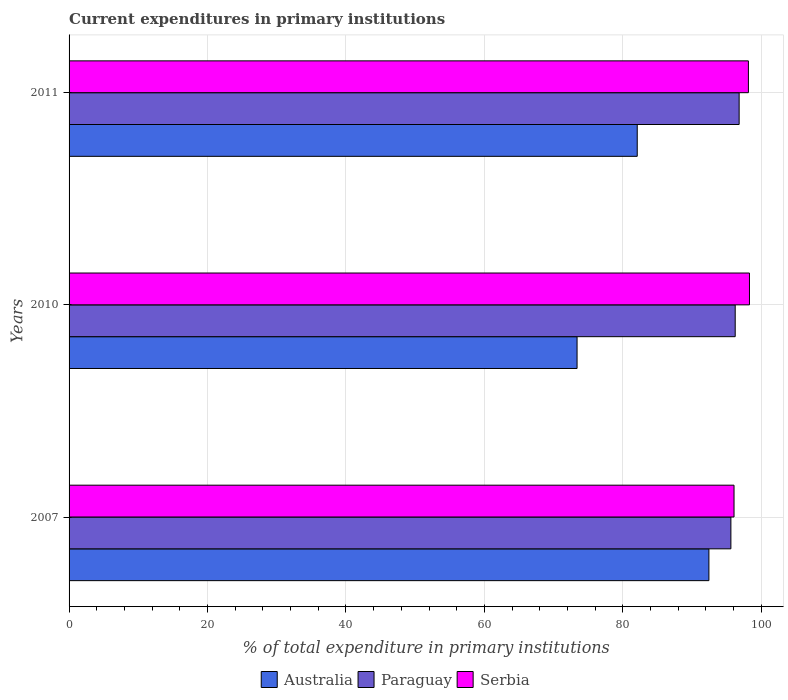How many groups of bars are there?
Your answer should be very brief. 3. Are the number of bars per tick equal to the number of legend labels?
Your answer should be compact. Yes. How many bars are there on the 3rd tick from the bottom?
Keep it short and to the point. 3. What is the label of the 3rd group of bars from the top?
Your answer should be very brief. 2007. In how many cases, is the number of bars for a given year not equal to the number of legend labels?
Your answer should be compact. 0. What is the current expenditures in primary institutions in Australia in 2007?
Ensure brevity in your answer.  92.42. Across all years, what is the maximum current expenditures in primary institutions in Serbia?
Provide a succinct answer. 98.28. Across all years, what is the minimum current expenditures in primary institutions in Paraguay?
Offer a very short reply. 95.6. What is the total current expenditures in primary institutions in Paraguay in the graph?
Your answer should be very brief. 288.61. What is the difference between the current expenditures in primary institutions in Australia in 2010 and that in 2011?
Provide a short and direct response. -8.69. What is the difference between the current expenditures in primary institutions in Serbia in 2011 and the current expenditures in primary institutions in Paraguay in 2007?
Keep it short and to the point. 2.53. What is the average current expenditures in primary institutions in Paraguay per year?
Give a very brief answer. 96.2. In the year 2011, what is the difference between the current expenditures in primary institutions in Serbia and current expenditures in primary institutions in Paraguay?
Your response must be concise. 1.34. What is the ratio of the current expenditures in primary institutions in Paraguay in 2007 to that in 2011?
Offer a very short reply. 0.99. What is the difference between the highest and the second highest current expenditures in primary institutions in Paraguay?
Your answer should be very brief. 0.57. What is the difference between the highest and the lowest current expenditures in primary institutions in Serbia?
Make the answer very short. 2.23. What does the 2nd bar from the top in 2011 represents?
Ensure brevity in your answer.  Paraguay. What does the 3rd bar from the bottom in 2007 represents?
Your response must be concise. Serbia. Are all the bars in the graph horizontal?
Make the answer very short. Yes. What is the difference between two consecutive major ticks on the X-axis?
Give a very brief answer. 20. Does the graph contain any zero values?
Your answer should be very brief. No. Does the graph contain grids?
Your answer should be compact. Yes. What is the title of the graph?
Your answer should be very brief. Current expenditures in primary institutions. Does "Papua New Guinea" appear as one of the legend labels in the graph?
Provide a short and direct response. No. What is the label or title of the X-axis?
Your answer should be very brief. % of total expenditure in primary institutions. What is the label or title of the Y-axis?
Keep it short and to the point. Years. What is the % of total expenditure in primary institutions of Australia in 2007?
Your answer should be very brief. 92.42. What is the % of total expenditure in primary institutions of Paraguay in 2007?
Your response must be concise. 95.6. What is the % of total expenditure in primary institutions of Serbia in 2007?
Keep it short and to the point. 96.05. What is the % of total expenditure in primary institutions in Australia in 2010?
Your answer should be very brief. 73.38. What is the % of total expenditure in primary institutions in Paraguay in 2010?
Your answer should be very brief. 96.22. What is the % of total expenditure in primary institutions of Serbia in 2010?
Offer a very short reply. 98.28. What is the % of total expenditure in primary institutions in Australia in 2011?
Offer a terse response. 82.07. What is the % of total expenditure in primary institutions of Paraguay in 2011?
Your response must be concise. 96.79. What is the % of total expenditure in primary institutions in Serbia in 2011?
Give a very brief answer. 98.13. Across all years, what is the maximum % of total expenditure in primary institutions in Australia?
Your answer should be compact. 92.42. Across all years, what is the maximum % of total expenditure in primary institutions in Paraguay?
Your answer should be compact. 96.79. Across all years, what is the maximum % of total expenditure in primary institutions of Serbia?
Your answer should be very brief. 98.28. Across all years, what is the minimum % of total expenditure in primary institutions in Australia?
Provide a short and direct response. 73.38. Across all years, what is the minimum % of total expenditure in primary institutions of Paraguay?
Your answer should be very brief. 95.6. Across all years, what is the minimum % of total expenditure in primary institutions of Serbia?
Your response must be concise. 96.05. What is the total % of total expenditure in primary institutions of Australia in the graph?
Your answer should be compact. 247.87. What is the total % of total expenditure in primary institutions of Paraguay in the graph?
Give a very brief answer. 288.61. What is the total % of total expenditure in primary institutions in Serbia in the graph?
Offer a very short reply. 292.46. What is the difference between the % of total expenditure in primary institutions in Australia in 2007 and that in 2010?
Offer a terse response. 19.04. What is the difference between the % of total expenditure in primary institutions in Paraguay in 2007 and that in 2010?
Offer a very short reply. -0.62. What is the difference between the % of total expenditure in primary institutions in Serbia in 2007 and that in 2010?
Your answer should be very brief. -2.23. What is the difference between the % of total expenditure in primary institutions of Australia in 2007 and that in 2011?
Ensure brevity in your answer.  10.35. What is the difference between the % of total expenditure in primary institutions in Paraguay in 2007 and that in 2011?
Ensure brevity in your answer.  -1.19. What is the difference between the % of total expenditure in primary institutions of Serbia in 2007 and that in 2011?
Offer a very short reply. -2.08. What is the difference between the % of total expenditure in primary institutions of Australia in 2010 and that in 2011?
Your answer should be very brief. -8.69. What is the difference between the % of total expenditure in primary institutions in Paraguay in 2010 and that in 2011?
Your response must be concise. -0.57. What is the difference between the % of total expenditure in primary institutions in Serbia in 2010 and that in 2011?
Make the answer very short. 0.15. What is the difference between the % of total expenditure in primary institutions in Australia in 2007 and the % of total expenditure in primary institutions in Paraguay in 2010?
Offer a terse response. -3.8. What is the difference between the % of total expenditure in primary institutions in Australia in 2007 and the % of total expenditure in primary institutions in Serbia in 2010?
Your answer should be compact. -5.86. What is the difference between the % of total expenditure in primary institutions in Paraguay in 2007 and the % of total expenditure in primary institutions in Serbia in 2010?
Offer a very short reply. -2.68. What is the difference between the % of total expenditure in primary institutions of Australia in 2007 and the % of total expenditure in primary institutions of Paraguay in 2011?
Make the answer very short. -4.37. What is the difference between the % of total expenditure in primary institutions in Australia in 2007 and the % of total expenditure in primary institutions in Serbia in 2011?
Give a very brief answer. -5.71. What is the difference between the % of total expenditure in primary institutions of Paraguay in 2007 and the % of total expenditure in primary institutions of Serbia in 2011?
Your answer should be very brief. -2.53. What is the difference between the % of total expenditure in primary institutions in Australia in 2010 and the % of total expenditure in primary institutions in Paraguay in 2011?
Provide a short and direct response. -23.41. What is the difference between the % of total expenditure in primary institutions of Australia in 2010 and the % of total expenditure in primary institutions of Serbia in 2011?
Provide a succinct answer. -24.75. What is the difference between the % of total expenditure in primary institutions of Paraguay in 2010 and the % of total expenditure in primary institutions of Serbia in 2011?
Provide a succinct answer. -1.91. What is the average % of total expenditure in primary institutions of Australia per year?
Give a very brief answer. 82.62. What is the average % of total expenditure in primary institutions in Paraguay per year?
Your response must be concise. 96.2. What is the average % of total expenditure in primary institutions in Serbia per year?
Keep it short and to the point. 97.49. In the year 2007, what is the difference between the % of total expenditure in primary institutions in Australia and % of total expenditure in primary institutions in Paraguay?
Make the answer very short. -3.18. In the year 2007, what is the difference between the % of total expenditure in primary institutions of Australia and % of total expenditure in primary institutions of Serbia?
Your answer should be compact. -3.63. In the year 2007, what is the difference between the % of total expenditure in primary institutions in Paraguay and % of total expenditure in primary institutions in Serbia?
Ensure brevity in your answer.  -0.45. In the year 2010, what is the difference between the % of total expenditure in primary institutions in Australia and % of total expenditure in primary institutions in Paraguay?
Provide a short and direct response. -22.84. In the year 2010, what is the difference between the % of total expenditure in primary institutions in Australia and % of total expenditure in primary institutions in Serbia?
Provide a succinct answer. -24.9. In the year 2010, what is the difference between the % of total expenditure in primary institutions of Paraguay and % of total expenditure in primary institutions of Serbia?
Offer a terse response. -2.06. In the year 2011, what is the difference between the % of total expenditure in primary institutions in Australia and % of total expenditure in primary institutions in Paraguay?
Provide a short and direct response. -14.72. In the year 2011, what is the difference between the % of total expenditure in primary institutions of Australia and % of total expenditure in primary institutions of Serbia?
Provide a succinct answer. -16.06. In the year 2011, what is the difference between the % of total expenditure in primary institutions in Paraguay and % of total expenditure in primary institutions in Serbia?
Offer a terse response. -1.34. What is the ratio of the % of total expenditure in primary institutions of Australia in 2007 to that in 2010?
Provide a short and direct response. 1.26. What is the ratio of the % of total expenditure in primary institutions of Serbia in 2007 to that in 2010?
Offer a terse response. 0.98. What is the ratio of the % of total expenditure in primary institutions in Australia in 2007 to that in 2011?
Make the answer very short. 1.13. What is the ratio of the % of total expenditure in primary institutions in Serbia in 2007 to that in 2011?
Keep it short and to the point. 0.98. What is the ratio of the % of total expenditure in primary institutions of Australia in 2010 to that in 2011?
Offer a terse response. 0.89. What is the ratio of the % of total expenditure in primary institutions in Paraguay in 2010 to that in 2011?
Offer a terse response. 0.99. What is the ratio of the % of total expenditure in primary institutions in Serbia in 2010 to that in 2011?
Make the answer very short. 1. What is the difference between the highest and the second highest % of total expenditure in primary institutions of Australia?
Your answer should be compact. 10.35. What is the difference between the highest and the second highest % of total expenditure in primary institutions in Paraguay?
Offer a terse response. 0.57. What is the difference between the highest and the second highest % of total expenditure in primary institutions in Serbia?
Give a very brief answer. 0.15. What is the difference between the highest and the lowest % of total expenditure in primary institutions in Australia?
Give a very brief answer. 19.04. What is the difference between the highest and the lowest % of total expenditure in primary institutions of Paraguay?
Give a very brief answer. 1.19. What is the difference between the highest and the lowest % of total expenditure in primary institutions in Serbia?
Your answer should be compact. 2.23. 